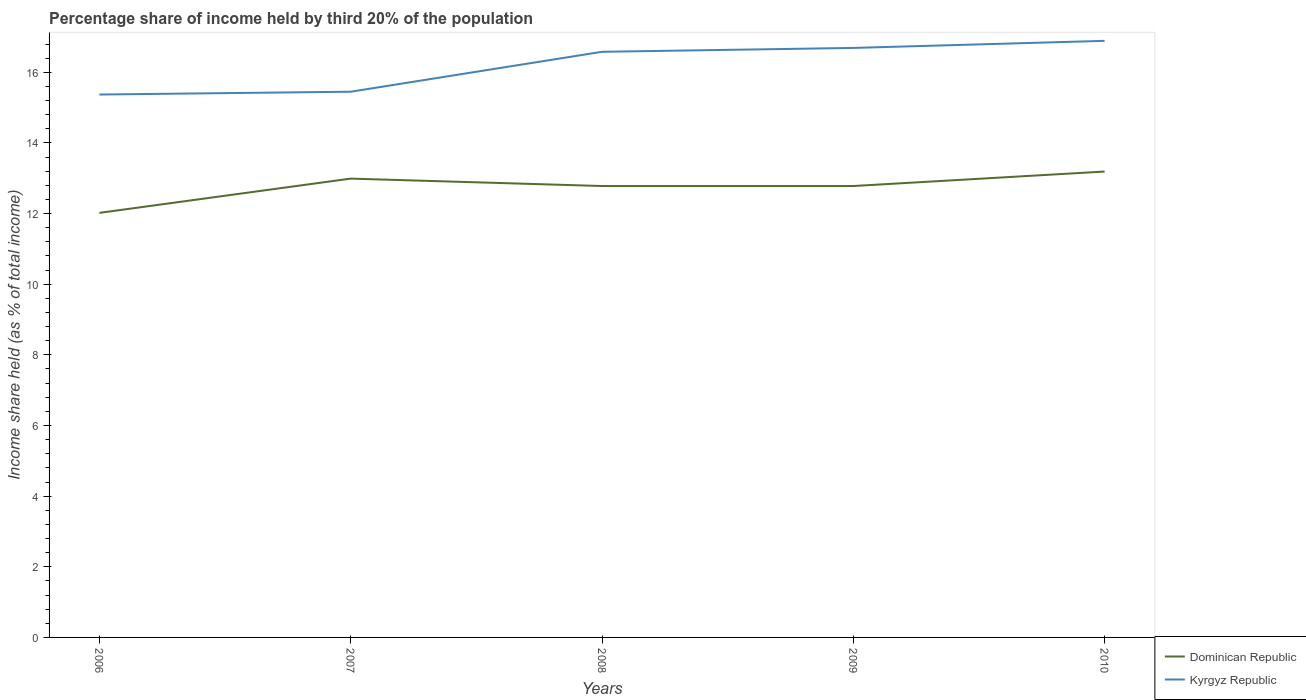How many different coloured lines are there?
Give a very brief answer. 2. Across all years, what is the maximum share of income held by third 20% of the population in Dominican Republic?
Give a very brief answer. 12.02. In which year was the share of income held by third 20% of the population in Kyrgyz Republic maximum?
Your answer should be compact. 2006. What is the total share of income held by third 20% of the population in Kyrgyz Republic in the graph?
Your response must be concise. -1.44. What is the difference between the highest and the second highest share of income held by third 20% of the population in Kyrgyz Republic?
Provide a short and direct response. 1.52. What is the difference between the highest and the lowest share of income held by third 20% of the population in Dominican Republic?
Keep it short and to the point. 4. Is the share of income held by third 20% of the population in Dominican Republic strictly greater than the share of income held by third 20% of the population in Kyrgyz Republic over the years?
Make the answer very short. Yes. What is the difference between two consecutive major ticks on the Y-axis?
Your answer should be very brief. 2. Does the graph contain grids?
Provide a succinct answer. No. How many legend labels are there?
Provide a succinct answer. 2. How are the legend labels stacked?
Keep it short and to the point. Vertical. What is the title of the graph?
Offer a very short reply. Percentage share of income held by third 20% of the population. Does "Panama" appear as one of the legend labels in the graph?
Keep it short and to the point. No. What is the label or title of the Y-axis?
Offer a terse response. Income share held (as % of total income). What is the Income share held (as % of total income) of Dominican Republic in 2006?
Offer a terse response. 12.02. What is the Income share held (as % of total income) in Kyrgyz Republic in 2006?
Your answer should be very brief. 15.37. What is the Income share held (as % of total income) in Dominican Republic in 2007?
Your response must be concise. 12.99. What is the Income share held (as % of total income) in Kyrgyz Republic in 2007?
Keep it short and to the point. 15.45. What is the Income share held (as % of total income) of Dominican Republic in 2008?
Offer a very short reply. 12.78. What is the Income share held (as % of total income) in Kyrgyz Republic in 2008?
Your answer should be compact. 16.58. What is the Income share held (as % of total income) in Dominican Republic in 2009?
Keep it short and to the point. 12.78. What is the Income share held (as % of total income) in Kyrgyz Republic in 2009?
Give a very brief answer. 16.69. What is the Income share held (as % of total income) in Dominican Republic in 2010?
Your answer should be very brief. 13.19. What is the Income share held (as % of total income) of Kyrgyz Republic in 2010?
Make the answer very short. 16.89. Across all years, what is the maximum Income share held (as % of total income) of Dominican Republic?
Make the answer very short. 13.19. Across all years, what is the maximum Income share held (as % of total income) of Kyrgyz Republic?
Provide a succinct answer. 16.89. Across all years, what is the minimum Income share held (as % of total income) in Dominican Republic?
Keep it short and to the point. 12.02. Across all years, what is the minimum Income share held (as % of total income) of Kyrgyz Republic?
Make the answer very short. 15.37. What is the total Income share held (as % of total income) in Dominican Republic in the graph?
Your response must be concise. 63.76. What is the total Income share held (as % of total income) of Kyrgyz Republic in the graph?
Your answer should be very brief. 80.98. What is the difference between the Income share held (as % of total income) in Dominican Republic in 2006 and that in 2007?
Make the answer very short. -0.97. What is the difference between the Income share held (as % of total income) in Kyrgyz Republic in 2006 and that in 2007?
Ensure brevity in your answer.  -0.08. What is the difference between the Income share held (as % of total income) of Dominican Republic in 2006 and that in 2008?
Your response must be concise. -0.76. What is the difference between the Income share held (as % of total income) of Kyrgyz Republic in 2006 and that in 2008?
Provide a succinct answer. -1.21. What is the difference between the Income share held (as % of total income) in Dominican Republic in 2006 and that in 2009?
Offer a terse response. -0.76. What is the difference between the Income share held (as % of total income) of Kyrgyz Republic in 2006 and that in 2009?
Give a very brief answer. -1.32. What is the difference between the Income share held (as % of total income) in Dominican Republic in 2006 and that in 2010?
Keep it short and to the point. -1.17. What is the difference between the Income share held (as % of total income) in Kyrgyz Republic in 2006 and that in 2010?
Offer a terse response. -1.52. What is the difference between the Income share held (as % of total income) in Dominican Republic in 2007 and that in 2008?
Offer a terse response. 0.21. What is the difference between the Income share held (as % of total income) of Kyrgyz Republic in 2007 and that in 2008?
Provide a short and direct response. -1.13. What is the difference between the Income share held (as % of total income) in Dominican Republic in 2007 and that in 2009?
Offer a terse response. 0.21. What is the difference between the Income share held (as % of total income) in Kyrgyz Republic in 2007 and that in 2009?
Offer a terse response. -1.24. What is the difference between the Income share held (as % of total income) of Dominican Republic in 2007 and that in 2010?
Offer a very short reply. -0.2. What is the difference between the Income share held (as % of total income) of Kyrgyz Republic in 2007 and that in 2010?
Your response must be concise. -1.44. What is the difference between the Income share held (as % of total income) of Dominican Republic in 2008 and that in 2009?
Give a very brief answer. 0. What is the difference between the Income share held (as % of total income) in Kyrgyz Republic in 2008 and that in 2009?
Make the answer very short. -0.11. What is the difference between the Income share held (as % of total income) of Dominican Republic in 2008 and that in 2010?
Offer a terse response. -0.41. What is the difference between the Income share held (as % of total income) in Kyrgyz Republic in 2008 and that in 2010?
Make the answer very short. -0.31. What is the difference between the Income share held (as % of total income) of Dominican Republic in 2009 and that in 2010?
Make the answer very short. -0.41. What is the difference between the Income share held (as % of total income) in Kyrgyz Republic in 2009 and that in 2010?
Your answer should be compact. -0.2. What is the difference between the Income share held (as % of total income) in Dominican Republic in 2006 and the Income share held (as % of total income) in Kyrgyz Republic in 2007?
Give a very brief answer. -3.43. What is the difference between the Income share held (as % of total income) of Dominican Republic in 2006 and the Income share held (as % of total income) of Kyrgyz Republic in 2008?
Make the answer very short. -4.56. What is the difference between the Income share held (as % of total income) in Dominican Republic in 2006 and the Income share held (as % of total income) in Kyrgyz Republic in 2009?
Your answer should be very brief. -4.67. What is the difference between the Income share held (as % of total income) of Dominican Republic in 2006 and the Income share held (as % of total income) of Kyrgyz Republic in 2010?
Offer a very short reply. -4.87. What is the difference between the Income share held (as % of total income) of Dominican Republic in 2007 and the Income share held (as % of total income) of Kyrgyz Republic in 2008?
Keep it short and to the point. -3.59. What is the difference between the Income share held (as % of total income) of Dominican Republic in 2007 and the Income share held (as % of total income) of Kyrgyz Republic in 2009?
Give a very brief answer. -3.7. What is the difference between the Income share held (as % of total income) in Dominican Republic in 2007 and the Income share held (as % of total income) in Kyrgyz Republic in 2010?
Give a very brief answer. -3.9. What is the difference between the Income share held (as % of total income) in Dominican Republic in 2008 and the Income share held (as % of total income) in Kyrgyz Republic in 2009?
Offer a terse response. -3.91. What is the difference between the Income share held (as % of total income) in Dominican Republic in 2008 and the Income share held (as % of total income) in Kyrgyz Republic in 2010?
Make the answer very short. -4.11. What is the difference between the Income share held (as % of total income) in Dominican Republic in 2009 and the Income share held (as % of total income) in Kyrgyz Republic in 2010?
Offer a terse response. -4.11. What is the average Income share held (as % of total income) of Dominican Republic per year?
Your answer should be compact. 12.75. What is the average Income share held (as % of total income) in Kyrgyz Republic per year?
Ensure brevity in your answer.  16.2. In the year 2006, what is the difference between the Income share held (as % of total income) of Dominican Republic and Income share held (as % of total income) of Kyrgyz Republic?
Offer a terse response. -3.35. In the year 2007, what is the difference between the Income share held (as % of total income) of Dominican Republic and Income share held (as % of total income) of Kyrgyz Republic?
Provide a short and direct response. -2.46. In the year 2008, what is the difference between the Income share held (as % of total income) of Dominican Republic and Income share held (as % of total income) of Kyrgyz Republic?
Make the answer very short. -3.8. In the year 2009, what is the difference between the Income share held (as % of total income) in Dominican Republic and Income share held (as % of total income) in Kyrgyz Republic?
Provide a short and direct response. -3.91. What is the ratio of the Income share held (as % of total income) of Dominican Republic in 2006 to that in 2007?
Keep it short and to the point. 0.93. What is the ratio of the Income share held (as % of total income) of Dominican Republic in 2006 to that in 2008?
Ensure brevity in your answer.  0.94. What is the ratio of the Income share held (as % of total income) in Kyrgyz Republic in 2006 to that in 2008?
Provide a short and direct response. 0.93. What is the ratio of the Income share held (as % of total income) of Dominican Republic in 2006 to that in 2009?
Ensure brevity in your answer.  0.94. What is the ratio of the Income share held (as % of total income) in Kyrgyz Republic in 2006 to that in 2009?
Make the answer very short. 0.92. What is the ratio of the Income share held (as % of total income) in Dominican Republic in 2006 to that in 2010?
Provide a short and direct response. 0.91. What is the ratio of the Income share held (as % of total income) in Kyrgyz Republic in 2006 to that in 2010?
Your answer should be compact. 0.91. What is the ratio of the Income share held (as % of total income) in Dominican Republic in 2007 to that in 2008?
Offer a very short reply. 1.02. What is the ratio of the Income share held (as % of total income) of Kyrgyz Republic in 2007 to that in 2008?
Offer a very short reply. 0.93. What is the ratio of the Income share held (as % of total income) in Dominican Republic in 2007 to that in 2009?
Offer a very short reply. 1.02. What is the ratio of the Income share held (as % of total income) in Kyrgyz Republic in 2007 to that in 2009?
Provide a short and direct response. 0.93. What is the ratio of the Income share held (as % of total income) of Dominican Republic in 2007 to that in 2010?
Provide a short and direct response. 0.98. What is the ratio of the Income share held (as % of total income) of Kyrgyz Republic in 2007 to that in 2010?
Offer a terse response. 0.91. What is the ratio of the Income share held (as % of total income) in Kyrgyz Republic in 2008 to that in 2009?
Your response must be concise. 0.99. What is the ratio of the Income share held (as % of total income) in Dominican Republic in 2008 to that in 2010?
Provide a short and direct response. 0.97. What is the ratio of the Income share held (as % of total income) in Kyrgyz Republic in 2008 to that in 2010?
Your response must be concise. 0.98. What is the ratio of the Income share held (as % of total income) in Dominican Republic in 2009 to that in 2010?
Keep it short and to the point. 0.97. What is the difference between the highest and the second highest Income share held (as % of total income) in Dominican Republic?
Provide a short and direct response. 0.2. What is the difference between the highest and the lowest Income share held (as % of total income) in Dominican Republic?
Give a very brief answer. 1.17. What is the difference between the highest and the lowest Income share held (as % of total income) of Kyrgyz Republic?
Make the answer very short. 1.52. 